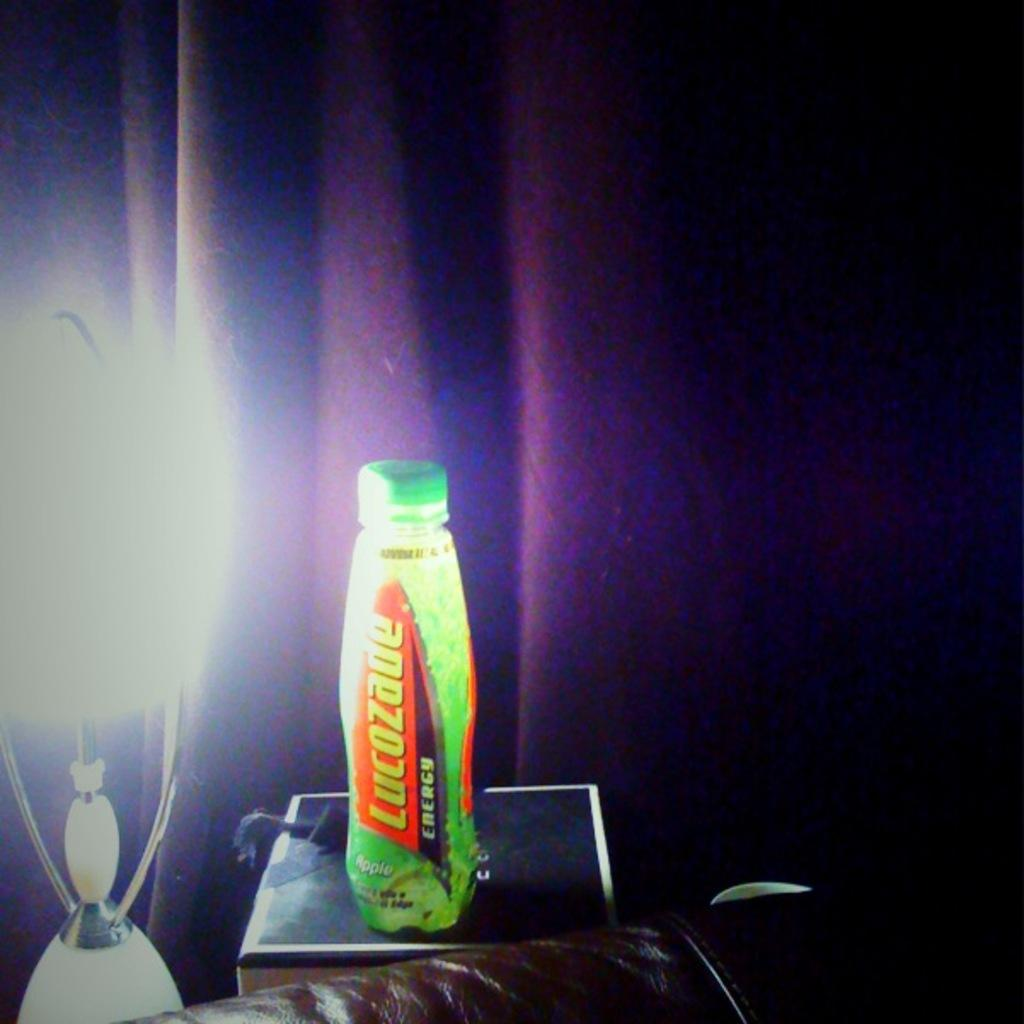<image>
Present a compact description of the photo's key features. Lucozade energy drink sitting on a box next to a light 